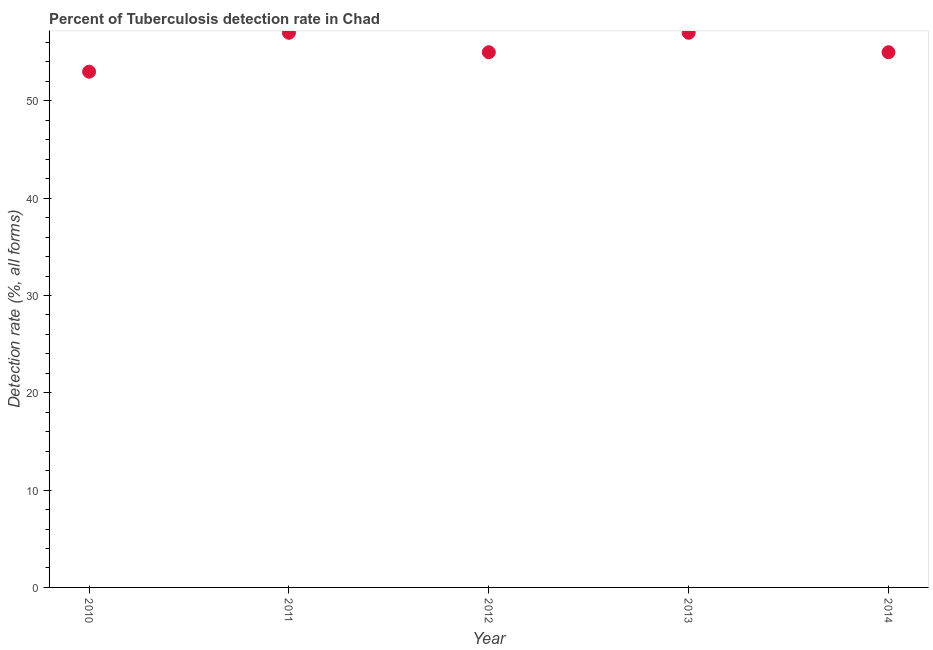What is the detection rate of tuberculosis in 2012?
Offer a terse response. 55. Across all years, what is the maximum detection rate of tuberculosis?
Ensure brevity in your answer.  57. Across all years, what is the minimum detection rate of tuberculosis?
Your answer should be very brief. 53. In which year was the detection rate of tuberculosis maximum?
Ensure brevity in your answer.  2011. What is the sum of the detection rate of tuberculosis?
Your answer should be compact. 277. What is the difference between the detection rate of tuberculosis in 2010 and 2013?
Your response must be concise. -4. What is the average detection rate of tuberculosis per year?
Keep it short and to the point. 55.4. What is the median detection rate of tuberculosis?
Keep it short and to the point. 55. In how many years, is the detection rate of tuberculosis greater than 6 %?
Your answer should be compact. 5. Do a majority of the years between 2014 and 2013 (inclusive) have detection rate of tuberculosis greater than 42 %?
Give a very brief answer. No. What is the ratio of the detection rate of tuberculosis in 2012 to that in 2013?
Make the answer very short. 0.96. Is the difference between the detection rate of tuberculosis in 2010 and 2013 greater than the difference between any two years?
Ensure brevity in your answer.  Yes. Is the sum of the detection rate of tuberculosis in 2013 and 2014 greater than the maximum detection rate of tuberculosis across all years?
Ensure brevity in your answer.  Yes. What is the difference between the highest and the lowest detection rate of tuberculosis?
Give a very brief answer. 4. In how many years, is the detection rate of tuberculosis greater than the average detection rate of tuberculosis taken over all years?
Give a very brief answer. 2. Does the detection rate of tuberculosis monotonically increase over the years?
Offer a very short reply. No. How many dotlines are there?
Your response must be concise. 1. How many years are there in the graph?
Keep it short and to the point. 5. Does the graph contain grids?
Keep it short and to the point. No. What is the title of the graph?
Provide a succinct answer. Percent of Tuberculosis detection rate in Chad. What is the label or title of the Y-axis?
Your answer should be very brief. Detection rate (%, all forms). What is the Detection rate (%, all forms) in 2010?
Make the answer very short. 53. What is the Detection rate (%, all forms) in 2011?
Provide a succinct answer. 57. What is the difference between the Detection rate (%, all forms) in 2010 and 2013?
Provide a short and direct response. -4. What is the difference between the Detection rate (%, all forms) in 2010 and 2014?
Ensure brevity in your answer.  -2. What is the difference between the Detection rate (%, all forms) in 2011 and 2012?
Give a very brief answer. 2. What is the difference between the Detection rate (%, all forms) in 2011 and 2013?
Make the answer very short. 0. What is the difference between the Detection rate (%, all forms) in 2011 and 2014?
Offer a terse response. 2. What is the difference between the Detection rate (%, all forms) in 2012 and 2013?
Your answer should be compact. -2. What is the difference between the Detection rate (%, all forms) in 2013 and 2014?
Offer a very short reply. 2. What is the ratio of the Detection rate (%, all forms) in 2010 to that in 2012?
Ensure brevity in your answer.  0.96. What is the ratio of the Detection rate (%, all forms) in 2010 to that in 2013?
Your answer should be compact. 0.93. What is the ratio of the Detection rate (%, all forms) in 2010 to that in 2014?
Provide a succinct answer. 0.96. What is the ratio of the Detection rate (%, all forms) in 2011 to that in 2012?
Ensure brevity in your answer.  1.04. What is the ratio of the Detection rate (%, all forms) in 2011 to that in 2013?
Offer a terse response. 1. What is the ratio of the Detection rate (%, all forms) in 2011 to that in 2014?
Give a very brief answer. 1.04. What is the ratio of the Detection rate (%, all forms) in 2012 to that in 2014?
Your answer should be very brief. 1. What is the ratio of the Detection rate (%, all forms) in 2013 to that in 2014?
Offer a terse response. 1.04. 